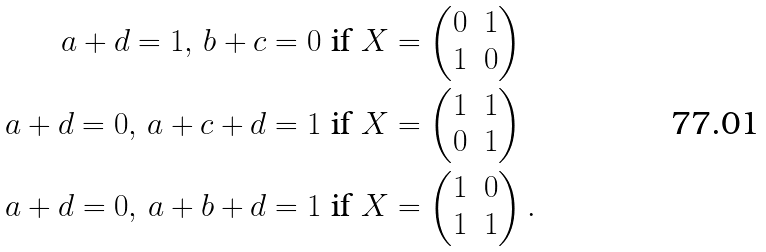<formula> <loc_0><loc_0><loc_500><loc_500>a + d = 1 , \, b + c = 0 & \text { if } X = \begin{pmatrix} 0 & 1 \\ 1 & 0 \end{pmatrix} \\ a + d = 0 , \, a + c + d = 1 & \text { if } X = \begin{pmatrix} 1 & 1 \\ 0 & 1 \end{pmatrix} \\ a + d = 0 , \, a + b + d = 1 & \text { if } X = \begin{pmatrix} 1 & 0 \\ 1 & 1 \end{pmatrix} .</formula> 